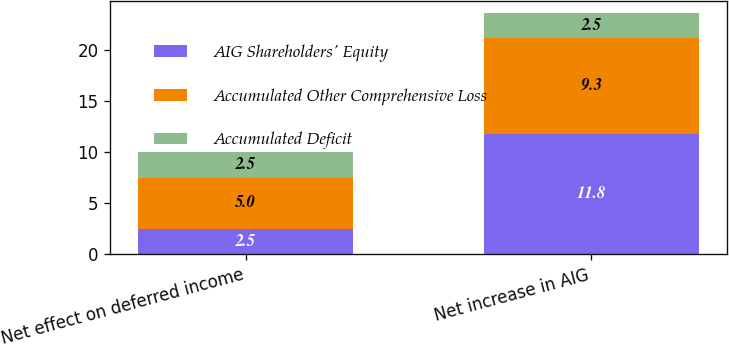<chart> <loc_0><loc_0><loc_500><loc_500><stacked_bar_chart><ecel><fcel>Net effect on deferred income<fcel>Net increase in AIG<nl><fcel>AIG Shareholders' Equity<fcel>2.5<fcel>11.8<nl><fcel>Accumulated Other Comprehensive Loss<fcel>5<fcel>9.3<nl><fcel>Accumulated Deficit<fcel>2.5<fcel>2.5<nl></chart> 